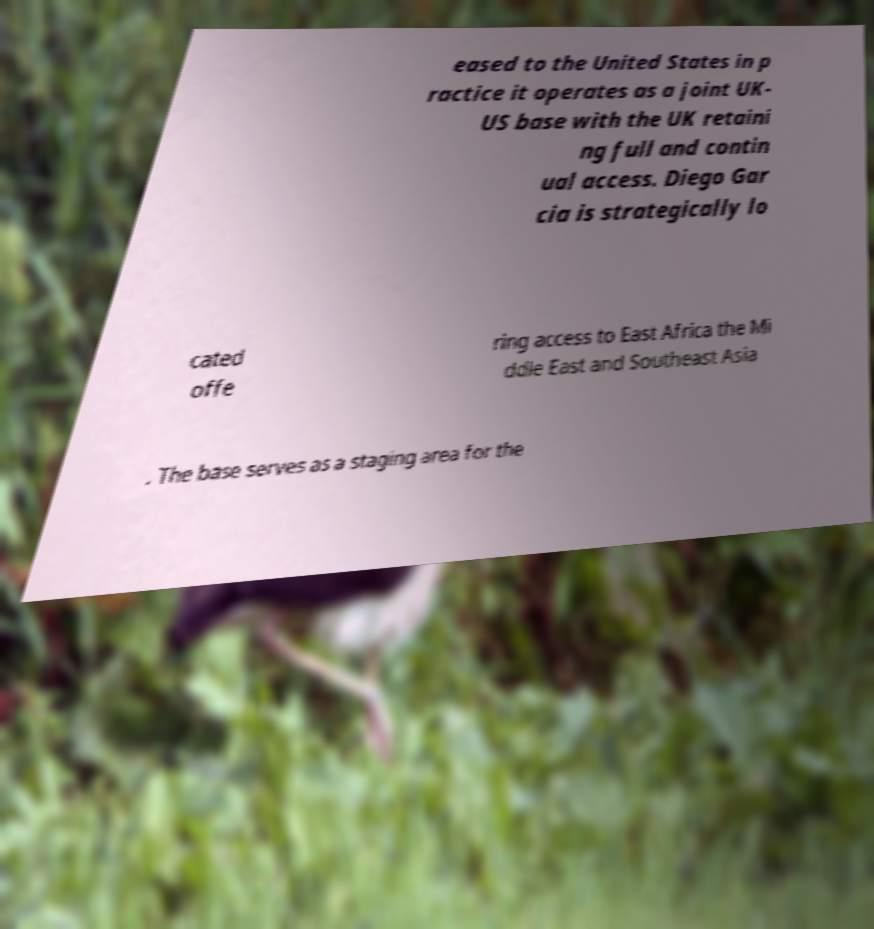Can you accurately transcribe the text from the provided image for me? eased to the United States in p ractice it operates as a joint UK- US base with the UK retaini ng full and contin ual access. Diego Gar cia is strategically lo cated offe ring access to East Africa the Mi ddle East and Southeast Asia . The base serves as a staging area for the 